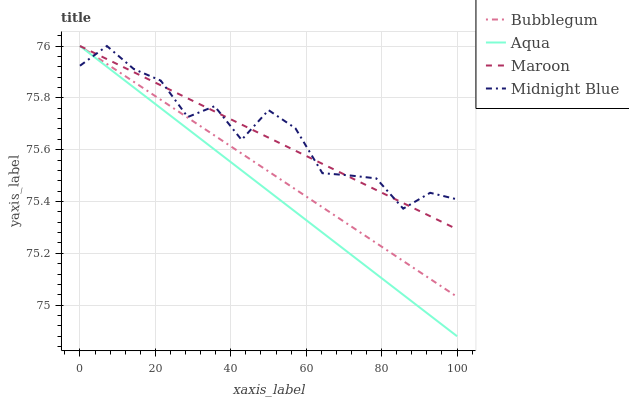Does Aqua have the minimum area under the curve?
Answer yes or no. Yes. Does Midnight Blue have the maximum area under the curve?
Answer yes or no. Yes. Does Maroon have the minimum area under the curve?
Answer yes or no. No. Does Maroon have the maximum area under the curve?
Answer yes or no. No. Is Aqua the smoothest?
Answer yes or no. Yes. Is Midnight Blue the roughest?
Answer yes or no. Yes. Is Maroon the smoothest?
Answer yes or no. No. Is Maroon the roughest?
Answer yes or no. No. Does Aqua have the lowest value?
Answer yes or no. Yes. Does Maroon have the lowest value?
Answer yes or no. No. Does Midnight Blue have the highest value?
Answer yes or no. Yes. Does Bubblegum intersect Midnight Blue?
Answer yes or no. Yes. Is Bubblegum less than Midnight Blue?
Answer yes or no. No. Is Bubblegum greater than Midnight Blue?
Answer yes or no. No. 